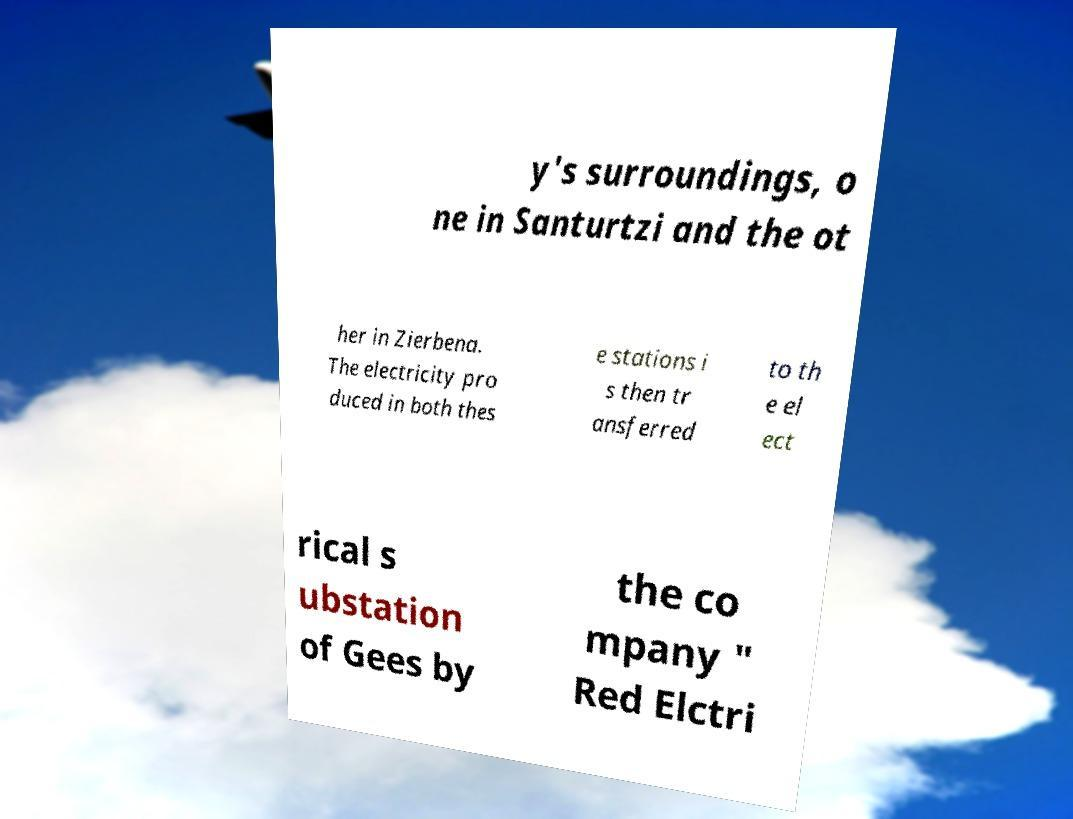Could you assist in decoding the text presented in this image and type it out clearly? y's surroundings, o ne in Santurtzi and the ot her in Zierbena. The electricity pro duced in both thes e stations i s then tr ansferred to th e el ect rical s ubstation of Gees by the co mpany " Red Elctri 